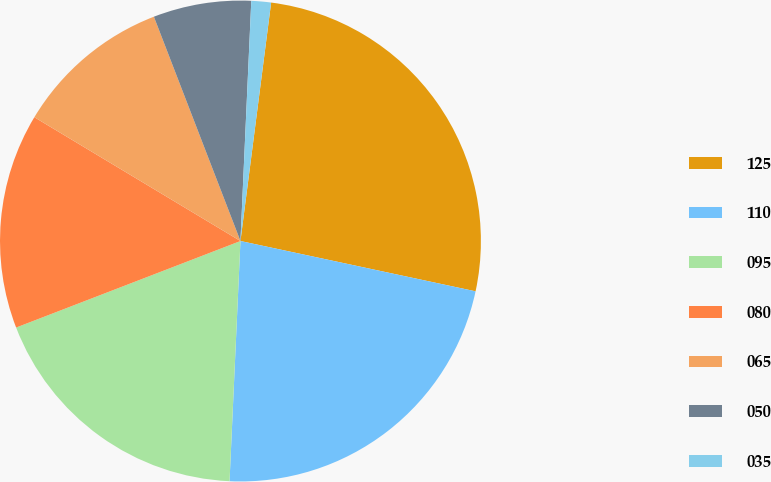Convert chart. <chart><loc_0><loc_0><loc_500><loc_500><pie_chart><fcel>125<fcel>110<fcel>095<fcel>080<fcel>065<fcel>050<fcel>035<nl><fcel>26.32%<fcel>22.37%<fcel>18.42%<fcel>14.47%<fcel>10.53%<fcel>6.58%<fcel>1.32%<nl></chart> 